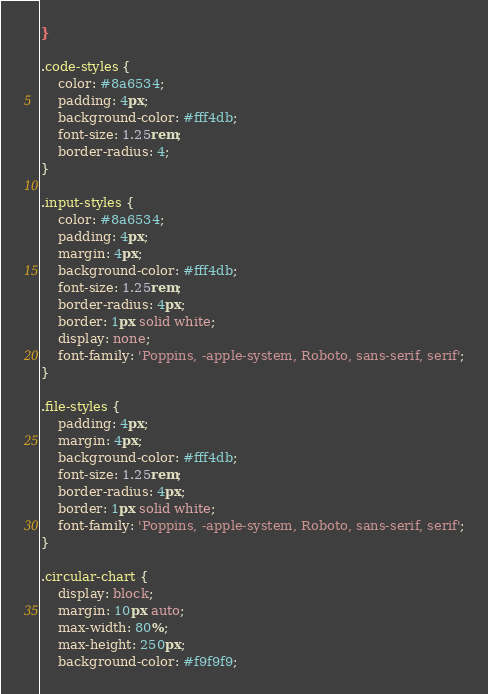Convert code to text. <code><loc_0><loc_0><loc_500><loc_500><_CSS_>}

.code-styles {
    color: #8a6534;
    padding: 4px;
    background-color: #fff4db;
    font-size: 1.25rem;
    border-radius: 4;
}

.input-styles {
    color: #8a6534;
    padding: 4px;
    margin: 4px;
    background-color: #fff4db;
    font-size: 1.25rem;
    border-radius: 4px;
    border: 1px solid white;
    display: none;
    font-family: 'Poppins, -apple-system, Roboto, sans-serif, serif';
}

.file-styles {
    padding: 4px;
    margin: 4px;
    background-color: #fff4db;
    font-size: 1.25rem;
    border-radius: 4px;
    border: 1px solid white;
    font-family: 'Poppins, -apple-system, Roboto, sans-serif, serif';
}

.circular-chart {
    display: block;
    margin: 10px auto;
    max-width: 80%;
    max-height: 250px;
    background-color: #f9f9f9;</code> 